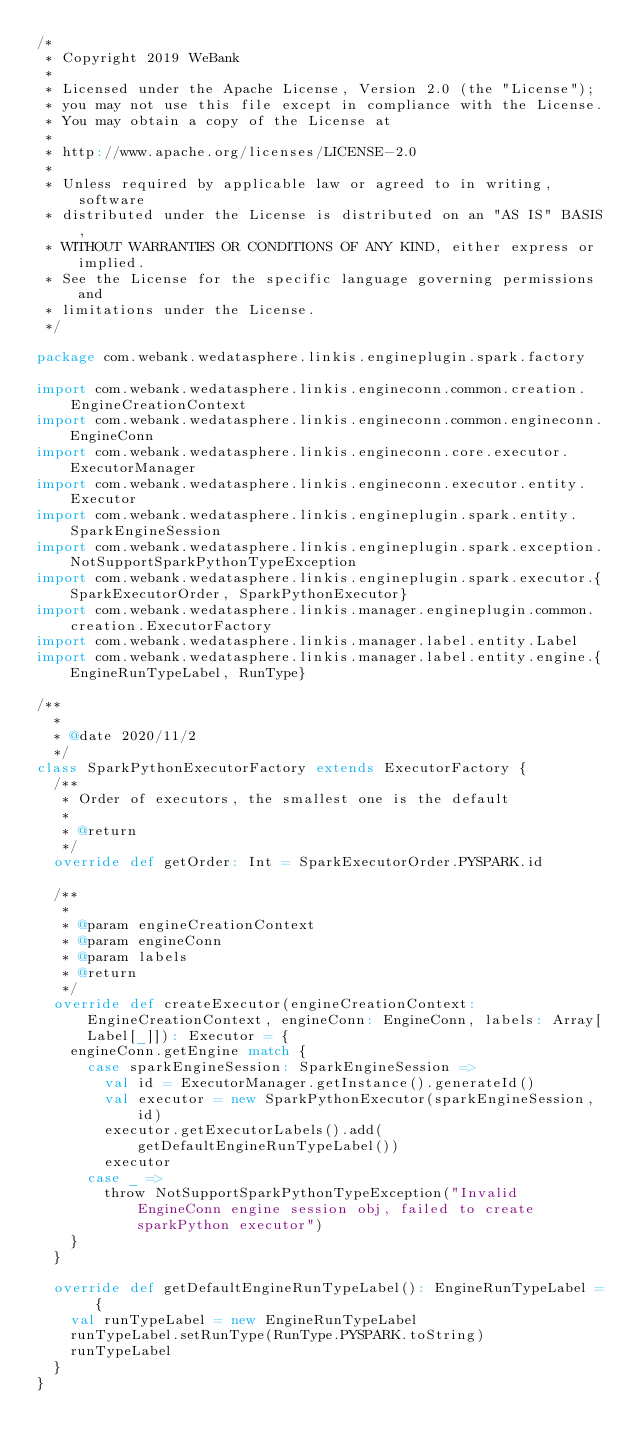<code> <loc_0><loc_0><loc_500><loc_500><_Scala_>/*
 * Copyright 2019 WeBank
 *
 * Licensed under the Apache License, Version 2.0 (the "License");
 * you may not use this file except in compliance with the License.
 * You may obtain a copy of the License at
 *
 * http://www.apache.org/licenses/LICENSE-2.0
 *
 * Unless required by applicable law or agreed to in writing, software
 * distributed under the License is distributed on an "AS IS" BASIS,
 * WITHOUT WARRANTIES OR CONDITIONS OF ANY KIND, either express or implied.
 * See the License for the specific language governing permissions and
 * limitations under the License.
 */

package com.webank.wedatasphere.linkis.engineplugin.spark.factory

import com.webank.wedatasphere.linkis.engineconn.common.creation.EngineCreationContext
import com.webank.wedatasphere.linkis.engineconn.common.engineconn.EngineConn
import com.webank.wedatasphere.linkis.engineconn.core.executor.ExecutorManager
import com.webank.wedatasphere.linkis.engineconn.executor.entity.Executor
import com.webank.wedatasphere.linkis.engineplugin.spark.entity.SparkEngineSession
import com.webank.wedatasphere.linkis.engineplugin.spark.exception.NotSupportSparkPythonTypeException
import com.webank.wedatasphere.linkis.engineplugin.spark.executor.{SparkExecutorOrder, SparkPythonExecutor}
import com.webank.wedatasphere.linkis.manager.engineplugin.common.creation.ExecutorFactory
import com.webank.wedatasphere.linkis.manager.label.entity.Label
import com.webank.wedatasphere.linkis.manager.label.entity.engine.{EngineRunTypeLabel, RunType}

/**
  *
  * @date 2020/11/2
  */
class SparkPythonExecutorFactory extends ExecutorFactory {
  /**
   * Order of executors, the smallest one is the default
   *
   * @return
   */
  override def getOrder: Int = SparkExecutorOrder.PYSPARK.id

  /**
   *
   * @param engineCreationContext
   * @param engineConn
   * @param labels
   * @return
   */
  override def createExecutor(engineCreationContext: EngineCreationContext, engineConn: EngineConn, labels: Array[Label[_]]): Executor = {
    engineConn.getEngine match {
      case sparkEngineSession: SparkEngineSession =>
        val id = ExecutorManager.getInstance().generateId()
        val executor = new SparkPythonExecutor(sparkEngineSession, id)
        executor.getExecutorLabels().add(getDefaultEngineRunTypeLabel())
        executor
      case _ =>
        throw NotSupportSparkPythonTypeException("Invalid EngineConn engine session obj, failed to create sparkPython executor")
    }
  }

  override def getDefaultEngineRunTypeLabel(): EngineRunTypeLabel = {
    val runTypeLabel = new EngineRunTypeLabel
    runTypeLabel.setRunType(RunType.PYSPARK.toString)
    runTypeLabel
  }
}
</code> 